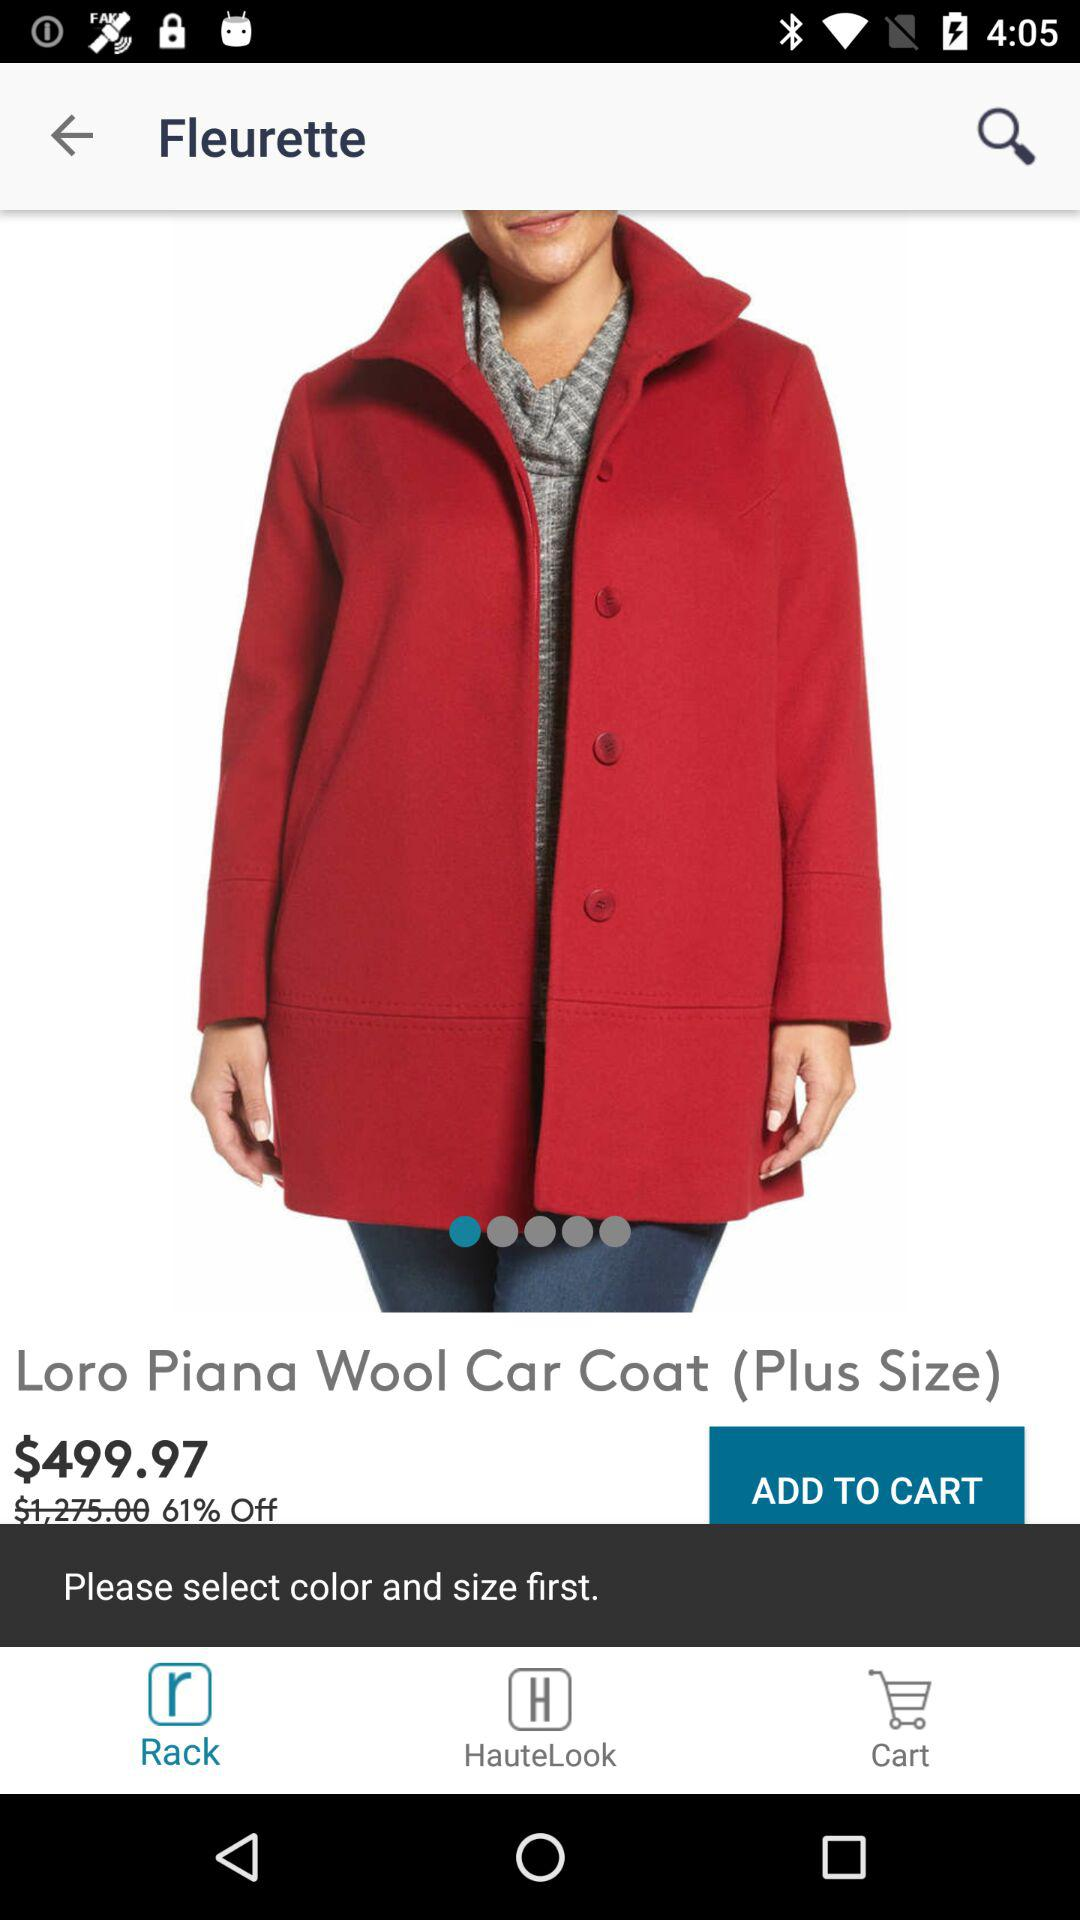What is the selected size? The selected size is "Plus Size". 